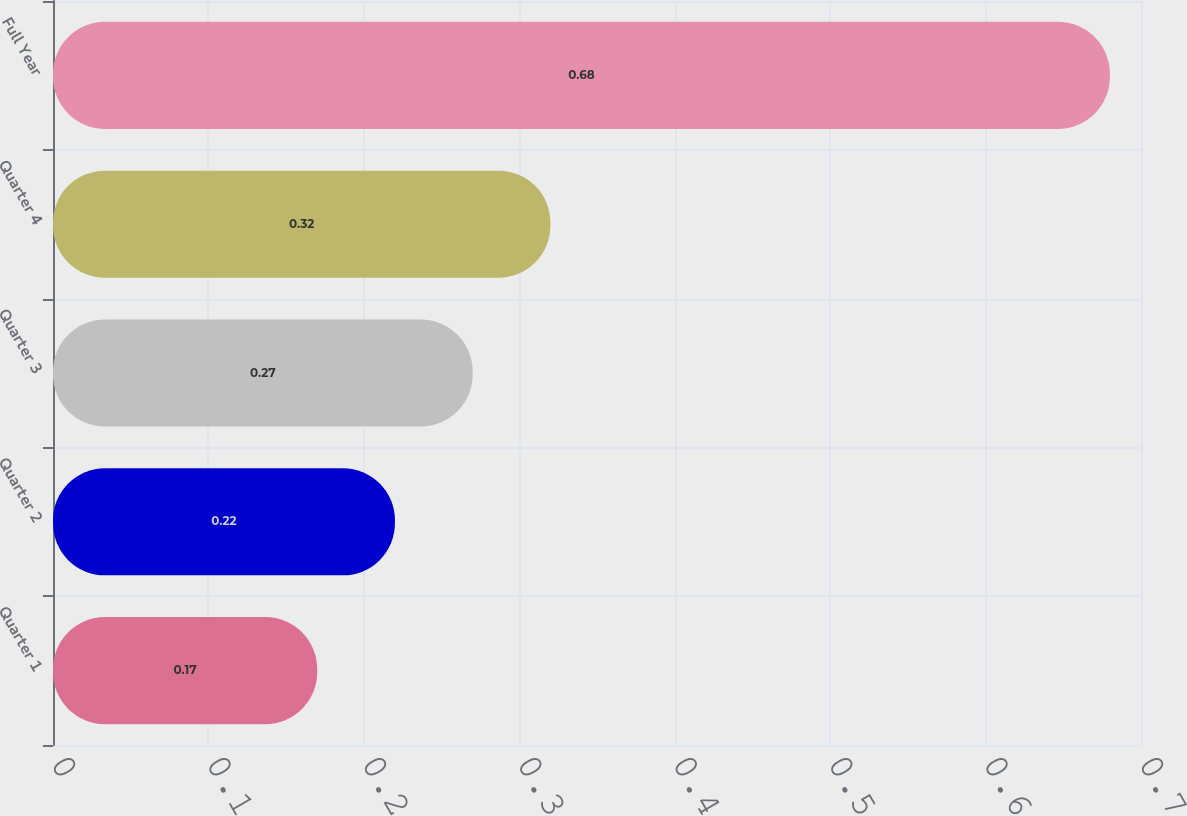Convert chart. <chart><loc_0><loc_0><loc_500><loc_500><bar_chart><fcel>Quarter 1<fcel>Quarter 2<fcel>Quarter 3<fcel>Quarter 4<fcel>Full Year<nl><fcel>0.17<fcel>0.22<fcel>0.27<fcel>0.32<fcel>0.68<nl></chart> 